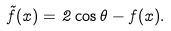<formula> <loc_0><loc_0><loc_500><loc_500>\tilde { f } ( x ) = 2 \cos \theta - f ( x ) .</formula> 